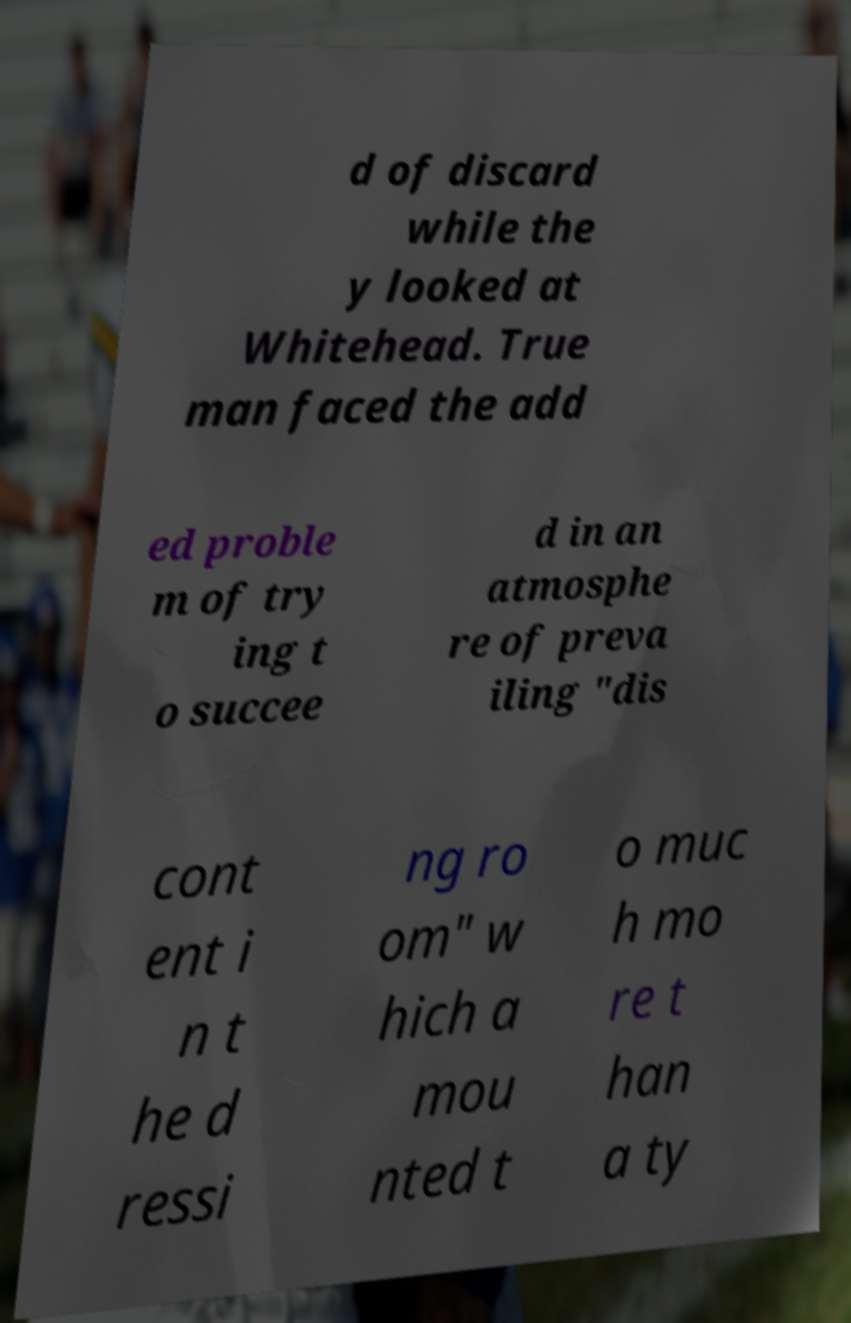Can you read and provide the text displayed in the image?This photo seems to have some interesting text. Can you extract and type it out for me? d of discard while the y looked at Whitehead. True man faced the add ed proble m of try ing t o succee d in an atmosphe re of preva iling "dis cont ent i n t he d ressi ng ro om" w hich a mou nted t o muc h mo re t han a ty 